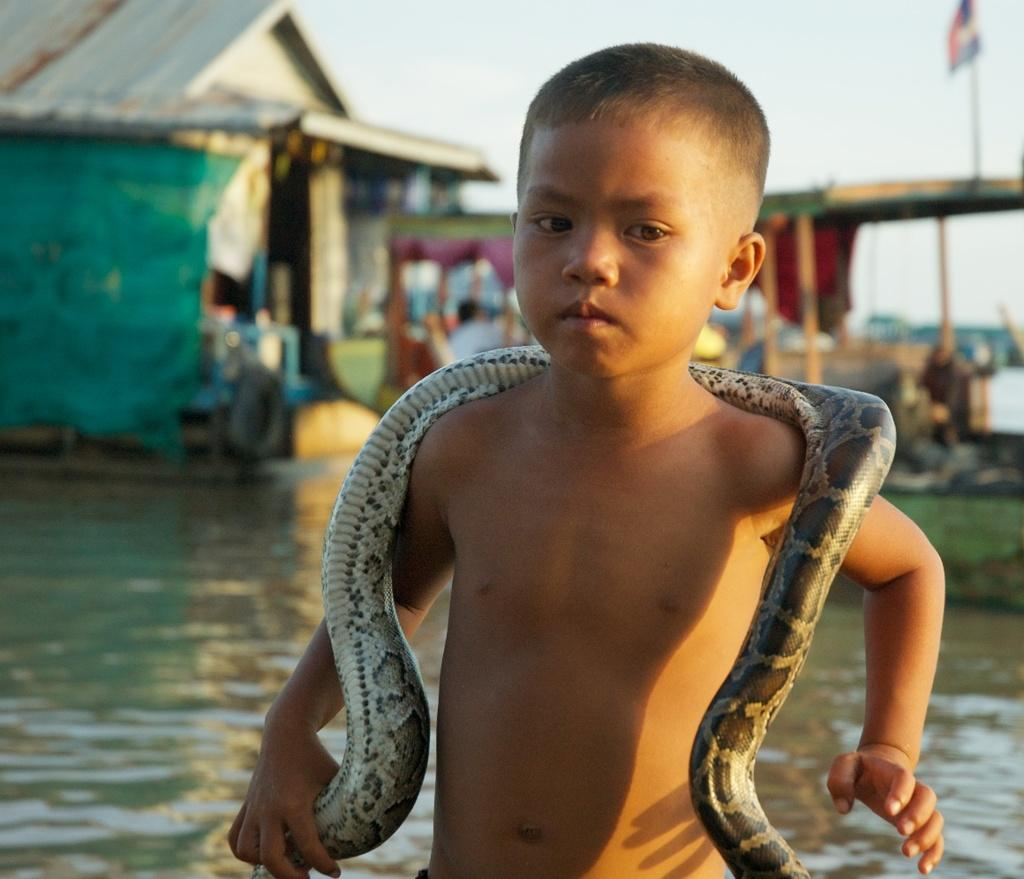What is the main subject of the image? There is a child in the image. What is the child holding in the image? The child is holding a snake. What can be seen in the background of the image? There is a hut, the sky, and a flag visible in the background of the image. Is there any water visible in the image? Yes, there is a river under the hut in the image. What type of substance is being used for the child's treatment in the image? There is no indication in the image that the child is receiving any treatment, and therefore no such substance can be observed. 